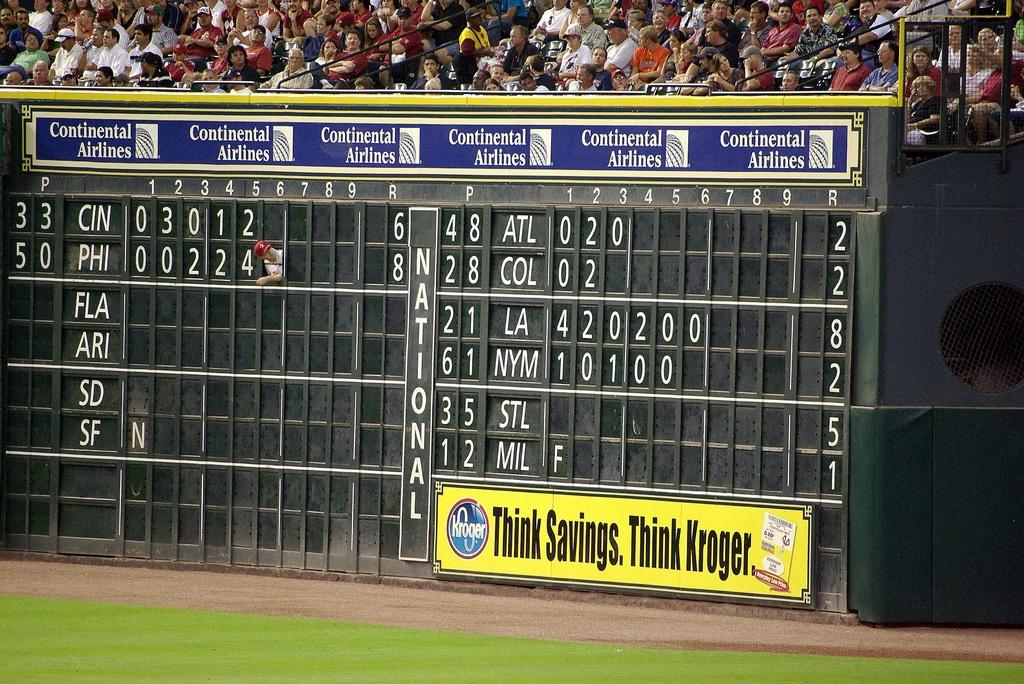<image>
Describe the image concisely. A scoreboard located under a stand of spectators has a man sticking his head and shoulder out of one of the score points for the Philadelphia team. 